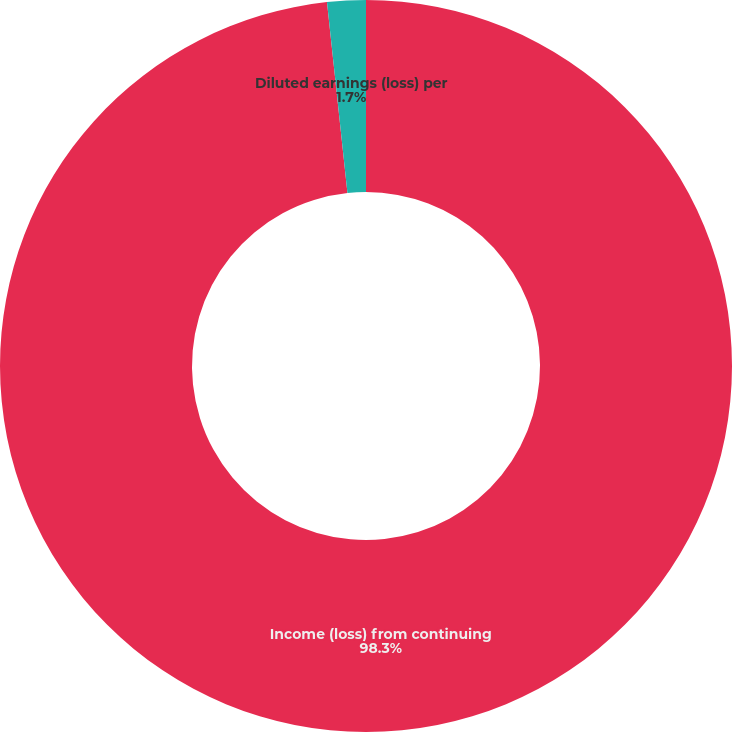<chart> <loc_0><loc_0><loc_500><loc_500><pie_chart><fcel>Income (loss) from continuing<fcel>Diluted earnings (loss) per<nl><fcel>98.3%<fcel>1.7%<nl></chart> 